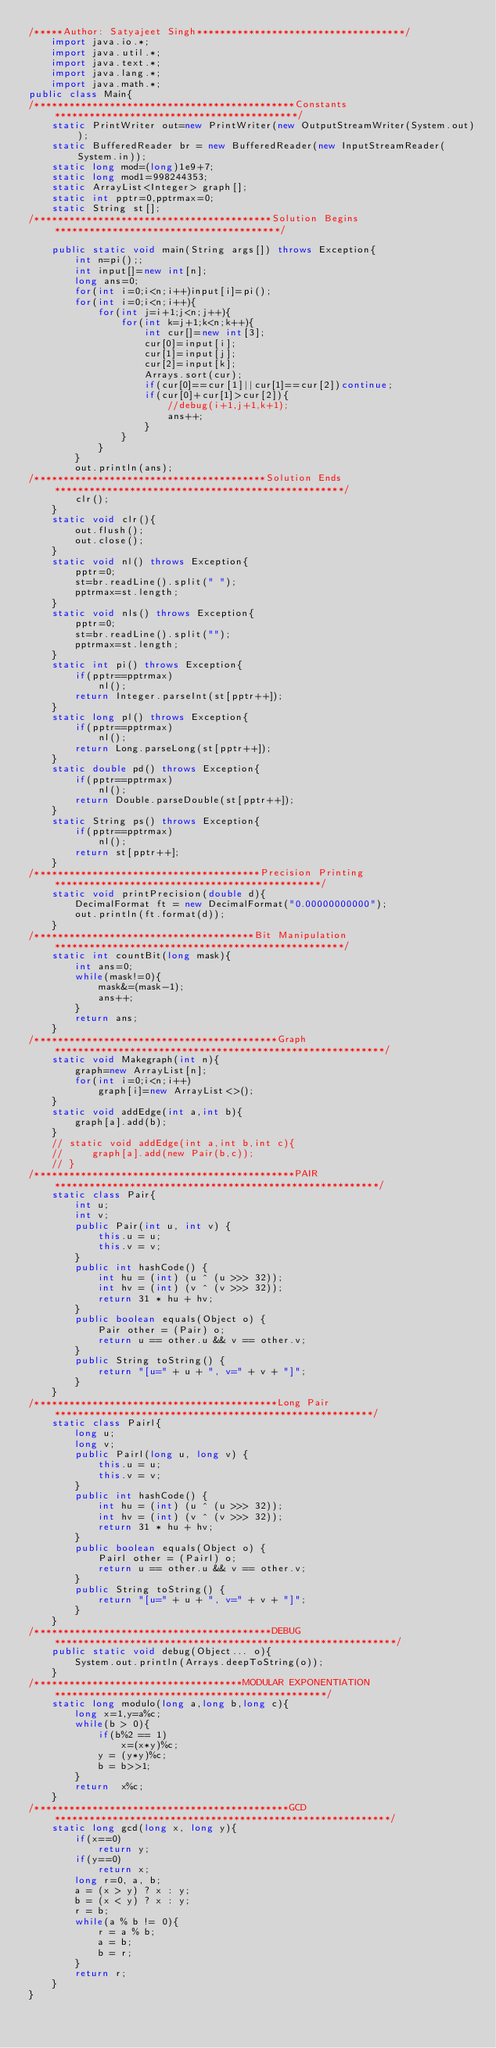Convert code to text. <code><loc_0><loc_0><loc_500><loc_500><_Java_>/*****Author: Satyajeet Singh************************************/
    import java.io.*;
    import java.util.*;
    import java.text.*; 
    import java.lang.*;
    import java.math.*;
public class Main{
/*********************************************Constants******************************************/
    static PrintWriter out=new PrintWriter(new OutputStreamWriter(System.out));        
    static BufferedReader br = new BufferedReader(new InputStreamReader(System.in));
    static long mod=(long)1e9+7;
    static long mod1=998244353;
    static ArrayList<Integer> graph[];
    static int pptr=0,pptrmax=0;
    static String st[];
/*****************************************Solution Begins***************************************/    
    
    public static void main(String args[]) throws Exception{      
        int n=pi();;
        int input[]=new int[n];
        long ans=0;
        for(int i=0;i<n;i++)input[i]=pi();
        for(int i=0;i<n;i++){
            for(int j=i+1;j<n;j++){
                for(int k=j+1;k<n;k++){
                    int cur[]=new int[3];
                    cur[0]=input[i];
                    cur[1]=input[j];
                    cur[2]=input[k];
                    Arrays.sort(cur);
                    if(cur[0]==cur[1]||cur[1]==cur[2])continue;
                    if(cur[0]+cur[1]>cur[2]){
                        //debug(i+1,j+1,k+1);
                        ans++;
                    }
                }
            }
        }
        out.println(ans);
/****************************************Solution Ends**************************************************/
        clr();
    }
    static void clr(){
        out.flush();
        out.close();
    }
    static void nl() throws Exception{
        pptr=0;
        st=br.readLine().split(" ");
        pptrmax=st.length;
    }
    static void nls() throws Exception{
        pptr=0;
        st=br.readLine().split("");
        pptrmax=st.length;
    }
    static int pi() throws Exception{
        if(pptr==pptrmax)
            nl();
        return Integer.parseInt(st[pptr++]);
    }
    static long pl() throws Exception{
        if(pptr==pptrmax)
            nl();
        return Long.parseLong(st[pptr++]);
    }
    static double pd() throws Exception{
        if(pptr==pptrmax)
            nl();
        return Double.parseDouble(st[pptr++]);
    }
    static String ps() throws Exception{
        if(pptr==pptrmax)
            nl();
        return st[pptr++];
    }
/***************************************Precision Printing**********************************************/
    static void printPrecision(double d){
        DecimalFormat ft = new DecimalFormat("0.00000000000"); 
        out.println(ft.format(d));
    }
/**************************************Bit Manipulation**************************************************/
    static int countBit(long mask){
        int ans=0;
        while(mask!=0){
            mask&=(mask-1);
            ans++;
        }
        return ans;
    }
/******************************************Graph*********************************************************/
    static void Makegraph(int n){
        graph=new ArrayList[n];
        for(int i=0;i<n;i++)
            graph[i]=new ArrayList<>();
    }
    static void addEdge(int a,int b){
        graph[a].add(b);
    }
    // static void addEdge(int a,int b,int c){
    //     graph[a].add(new Pair(b,c));
    // }    
/*********************************************PAIR********************************************************/
    static class Pair{
        int u;
        int v;
        public Pair(int u, int v) {
            this.u = u;
            this.v = v;
        }
        public int hashCode() {
            int hu = (int) (u ^ (u >>> 32));
            int hv = (int) (v ^ (v >>> 32));
            return 31 * hu + hv;
        }
        public boolean equals(Object o) {
            Pair other = (Pair) o;
            return u == other.u && v == other.v;
        }
        public String toString() {
            return "[u=" + u + ", v=" + v + "]";
        }
    }
/******************************************Long Pair*******************************************************/
    static class Pairl{
        long u;
        long v;
        public Pairl(long u, long v) {
            this.u = u;
            this.v = v;
        }
        public int hashCode() {
            int hu = (int) (u ^ (u >>> 32));
            int hv = (int) (v ^ (v >>> 32));
            return 31 * hu + hv;
        }
        public boolean equals(Object o) {
            Pairl other = (Pairl) o;
            return u == other.u && v == other.v;
        }
        public String toString() {
            return "[u=" + u + ", v=" + v + "]";
        }
    }
/*****************************************DEBUG***********************************************************/
    public static void debug(Object... o){
        System.out.println(Arrays.deepToString(o));
    }
/************************************MODULAR EXPONENTIATION***********************************************/
    static long modulo(long a,long b,long c){
        long x=1,y=a%c;
        while(b > 0){
            if(b%2 == 1)
                x=(x*y)%c;
            y = (y*y)%c;
            b = b>>1;
        }
        return  x%c;
    }
/********************************************GCD**********************************************************/
    static long gcd(long x, long y){
        if(x==0)
            return y;
        if(y==0)
            return x;
        long r=0, a, b;
        a = (x > y) ? x : y; 
        b = (x < y) ? x : y;
        r = b;
        while(a % b != 0){
            r = a % b;
            a = b;
            b = r;
        }
        return r;
    }
}</code> 